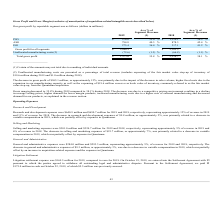According to On Semiconductor's financial document, How much was the expensing of the fair market value step-up of inventory during 2019? According to the financial document, $19.6 million. The relevant text states: "g of the fair market value step-up of inventory of $19.6 million during 2019 and $1.0 million during 2018)...." Also, How much was the expensing of the fair market value step-up of inventory during 2019? According to the financial document, $1.0 million. The relevant text states: "p-up of inventory of $19.6 million during 2019 and $1.0 million during 2018)...." Also, What is the gross profit from PSG in 2019? According to the financial document, $976.0 (in millions). The relevant text states: "PSG $ 976.0 35.0 % $ 1,110.1 36.5 %..." Also, can you calculate: What is the change in gross profit from PSG from 2018 to 2019? Based on the calculation: 976.0-1,110.1, the result is -134.1 (in millions). This is based on the information: "PSG $ 976.0 35.0 % $ 1,110.1 36.5 % PSG $ 976.0 35.0 % $ 1,110.1 36.5 %..." The key data points involved are: 1,110.1, 976.0. Also, can you calculate: What is the change in gross profit from ASG from 2018 to 2019? Based on the calculation: 794.8-878.3, the result is -83.5 (in millions). This is based on the information: "ASG 794.8 40.3 % 878.3 42.4 % ASG 794.8 40.3 % 878.3 42.4 %..." The key data points involved are: 794.8, 878.3. Also, can you calculate: What is the average gross profit from PSG for 2018 and 2019? To answer this question, I need to perform calculations using the financial data. The calculation is: (976.0+1,110.1) / 2, which equals 1043.05 (in millions). This is based on the information: "PSG $ 976.0 35.0 % $ 1,110.1 36.5 % PSG $ 976.0 35.0 % $ 1,110.1 36.5 %..." The key data points involved are: 1,110.1, 976.0. 